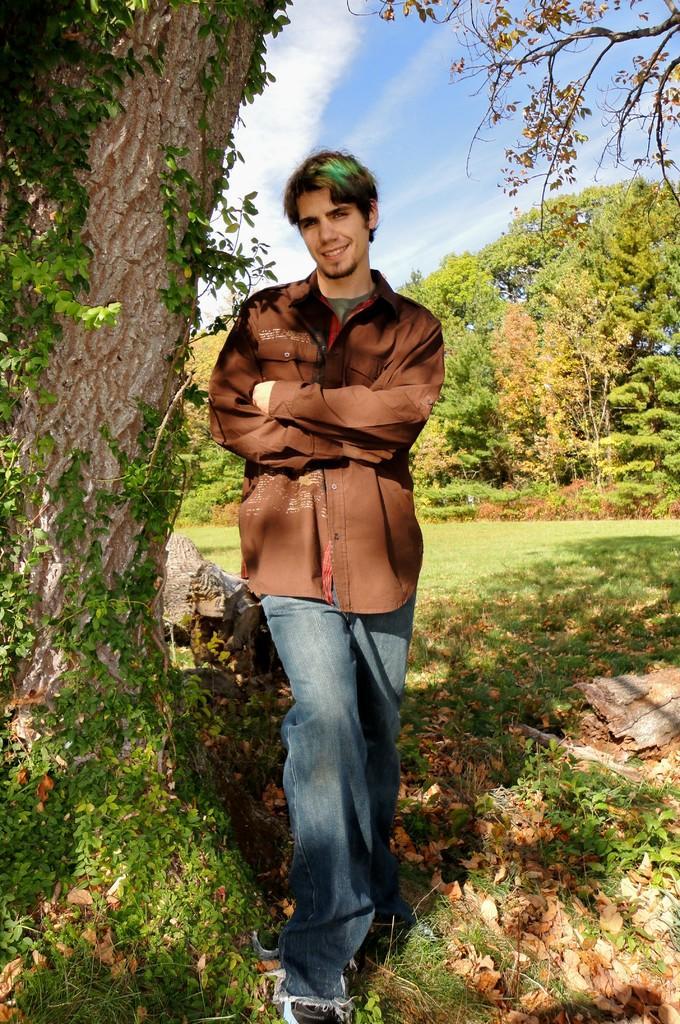How would you summarize this image in a sentence or two? In this picture we can observe a person standing wearing brown color shirt and he is smiling. He is standing beside a tree. There are some plants on the ground. We can observe some grass here. In the background there are trees and a sky with some clouds. 